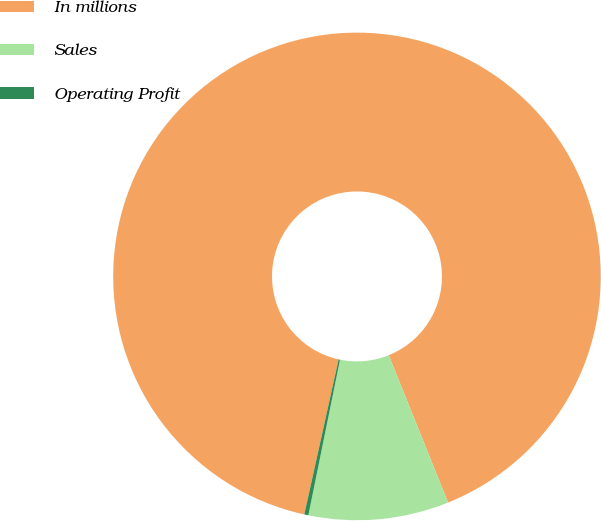Convert chart. <chart><loc_0><loc_0><loc_500><loc_500><pie_chart><fcel>In millions<fcel>Sales<fcel>Operating Profit<nl><fcel>90.44%<fcel>9.29%<fcel>0.27%<nl></chart> 